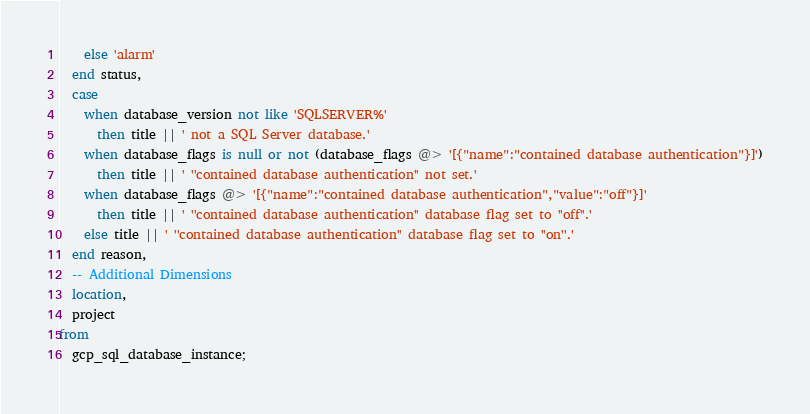<code> <loc_0><loc_0><loc_500><loc_500><_SQL_>    else 'alarm'
  end status,
  case
    when database_version not like 'SQLSERVER%'
      then title || ' not a SQL Server database.'
    when database_flags is null or not (database_flags @> '[{"name":"contained database authentication"}]')
      then title || ' ''contained database authentication'' not set.'
    when database_flags @> '[{"name":"contained database authentication","value":"off"}]'
      then title || ' ''contained database authentication'' database flag set to ''off''.'
    else title || ' ''contained database authentication'' database flag set to ''on''.'
  end reason,
  -- Additional Dimensions
  location,
  project
from
  gcp_sql_database_instance;</code> 